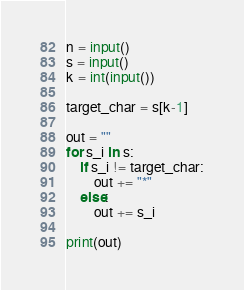Convert code to text. <code><loc_0><loc_0><loc_500><loc_500><_Python_>n = input()
s = input()
k = int(input())

target_char = s[k-1]

out = ""
for s_i in s:
	if s_i != target_char:
		out += "*"
	else:
		out += s_i

print(out)</code> 